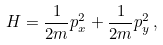<formula> <loc_0><loc_0><loc_500><loc_500>H = \frac { 1 } { 2 m } p _ { x } ^ { 2 } + \frac { 1 } { 2 m } p _ { y } ^ { 2 } \, ,</formula> 